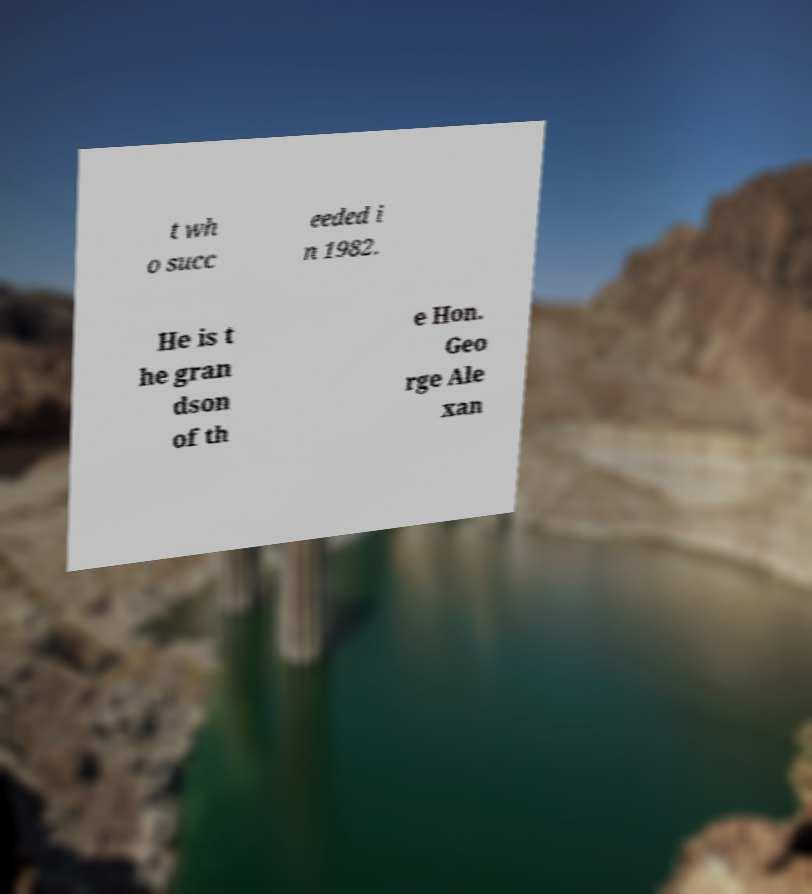What messages or text are displayed in this image? I need them in a readable, typed format. t wh o succ eeded i n 1982. He is t he gran dson of th e Hon. Geo rge Ale xan 